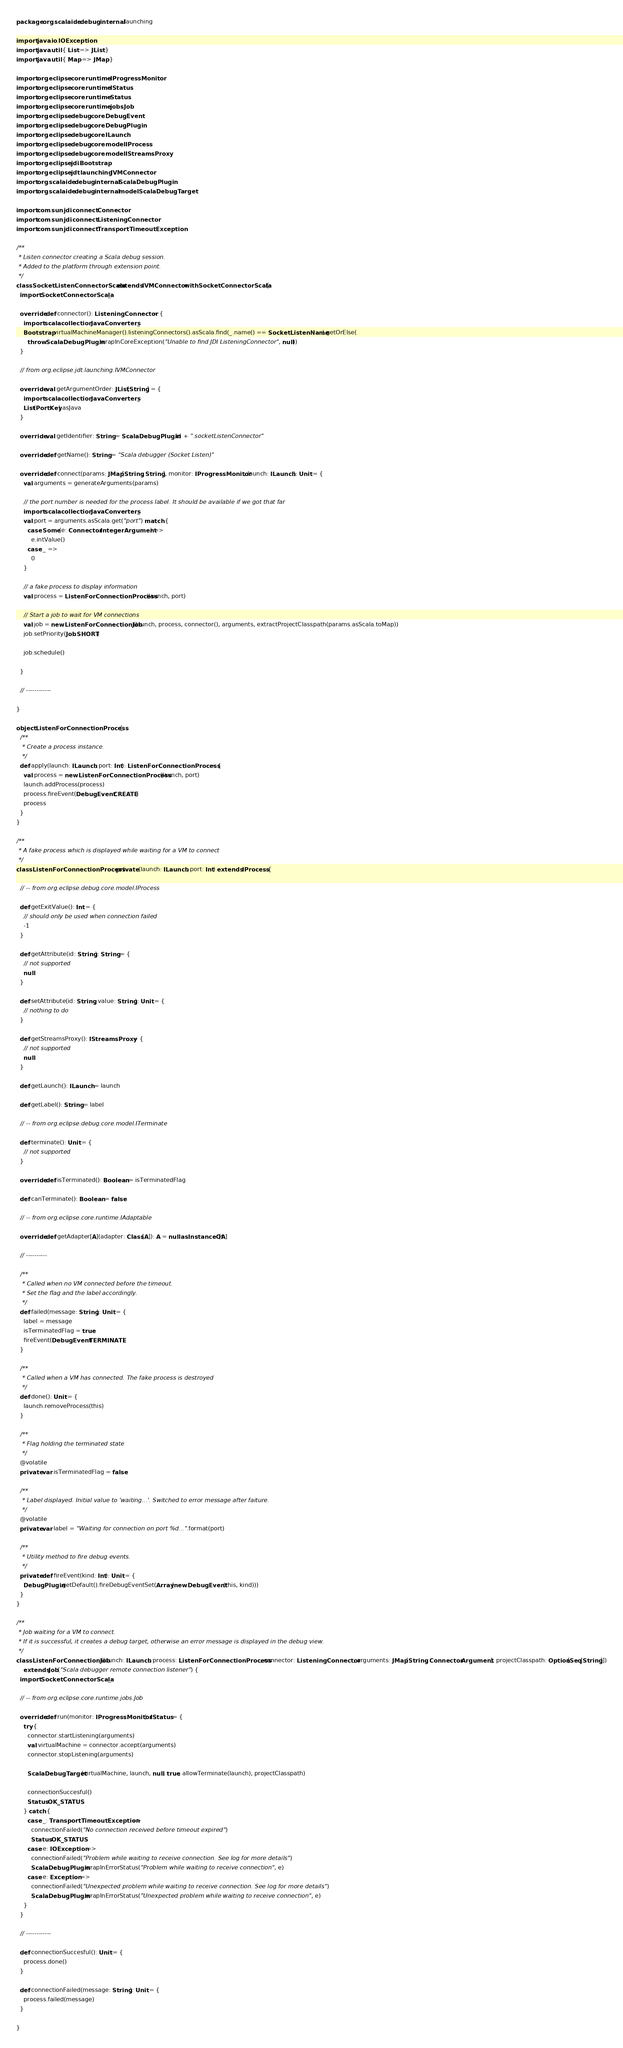<code> <loc_0><loc_0><loc_500><loc_500><_Scala_>package org.scalaide.debug.internal.launching

import java.io.IOException
import java.util.{ List => JList }
import java.util.{ Map => JMap }

import org.eclipse.core.runtime.IProgressMonitor
import org.eclipse.core.runtime.IStatus
import org.eclipse.core.runtime.Status
import org.eclipse.core.runtime.jobs.Job
import org.eclipse.debug.core.DebugEvent
import org.eclipse.debug.core.DebugPlugin
import org.eclipse.debug.core.ILaunch
import org.eclipse.debug.core.model.IProcess
import org.eclipse.debug.core.model.IStreamsProxy
import org.eclipse.jdi.Bootstrap
import org.eclipse.jdt.launching.IVMConnector
import org.scalaide.debug.internal.ScalaDebugPlugin
import org.scalaide.debug.internal.model.ScalaDebugTarget

import com.sun.jdi.connect.Connector
import com.sun.jdi.connect.ListeningConnector
import com.sun.jdi.connect.TransportTimeoutException

/**
 * Listen connector creating a Scala debug session.
 * Added to the platform through extension point.
 */
class SocketListenConnectorScala extends IVMConnector with SocketConnectorScala {
  import SocketConnectorScala._

  override def connector(): ListeningConnector = {
    import scala.collection.JavaConverters._
    Bootstrap.virtualMachineManager().listeningConnectors().asScala.find(_.name() == SocketListenName).getOrElse(
      throw ScalaDebugPlugin.wrapInCoreException("Unable to find JDI ListeningConnector", null))
  }

  // from org.eclipse.jdt.launching.IVMConnector

  override val getArgumentOrder: JList[String] = {
    import scala.collection.JavaConverters._
    List(PortKey).asJava
  }

  override val getIdentifier: String = ScalaDebugPlugin.id + ".socketListenConnector"

  override def getName(): String = "Scala debugger (Socket Listen)"

  override def connect(params: JMap[String, String], monitor: IProgressMonitor, launch: ILaunch): Unit = {
    val arguments = generateArguments(params)

    // the port number is needed for the process label. It should be available if we got that far
    import scala.collection.JavaConverters._
    val port = arguments.asScala.get("port") match {
      case Some(e: Connector.IntegerArgument) =>
        e.intValue()
      case _ =>
        0
    }

    // a fake process to display information
    val process = ListenForConnectionProcess(launch, port)

    // Start a job to wait for VM connections
    val job = new ListenForConnectionJob(launch, process, connector(), arguments, extractProjectClasspath(params.asScala.toMap))
    job.setPriority(Job.SHORT)

    job.schedule()

  }

  // ------------

}

object ListenForConnectionProcess {
  /**
   * Create a process instance.
   */
  def apply(launch: ILaunch, port: Int): ListenForConnectionProcess = {
    val process = new ListenForConnectionProcess(launch, port)
    launch.addProcess(process)
    process.fireEvent(DebugEvent.CREATE)
    process
  }
}

/**
 * A fake process which is displayed while waiting for a VM to connect
 */
class ListenForConnectionProcess private (launch: ILaunch, port: Int) extends IProcess {

  // -- from org.eclipse.debug.core.model.IProcess

  def getExitValue(): Int = {
    // should only be used when connection failed
    -1
  }

  def getAttribute(id: String): String = {
    // not supported
    null
  }

  def setAttribute(id: String, value: String): Unit = {
    // nothing to do
  }

  def getStreamsProxy(): IStreamsProxy = {
    // not supported
    null
  }

  def getLaunch(): ILaunch = launch

  def getLabel(): String = label

  // -- from org.eclipse.debug.core.model.ITerminate

  def terminate(): Unit = {
    // not supported
  }

  override def isTerminated(): Boolean = isTerminatedFlag

  def canTerminate(): Boolean = false

  // -- from org.eclipse.core.runtime.IAdaptable

  override def getAdapter[A](adapter: Class[A]): A = null.asInstanceOf[A]

  // ----------

  /**
   * Called when no VM connected before the timeout.
   * Set the flag and the label accordingly.
   */
  def failed(message: String): Unit = {
    label = message
    isTerminatedFlag = true
    fireEvent(DebugEvent.TERMINATE)
  }

  /**
   * Called when a VM has connected. The fake process is destroyed
   */
  def done(): Unit = {
    launch.removeProcess(this)
  }

  /**
   * Flag holding the terminated state
   */
  @volatile
  private var isTerminatedFlag = false

  /**
   * Label displayed. Initial value to 'waiting...'. Switched to error message after faiture.
   */
  @volatile
  private var label = "Waiting for connection on port %d...".format(port)

  /**
   * Utility method to fire debug events.
   */
  private def fireEvent(kind: Int): Unit = {
    DebugPlugin.getDefault().fireDebugEventSet(Array(new DebugEvent(this, kind)))
  }
}

/**
 * Job waiting for a VM to connect.
 * If it is successful, it creates a debug target, otherwise an error message is displayed in the debug view.
 */
class ListenForConnectionJob(launch: ILaunch, process: ListenForConnectionProcess, connector: ListeningConnector, arguments: JMap[String, Connector.Argument], projectClasspath: Option[Seq[String]])
    extends Job("Scala debugger remote connection listener") {
  import SocketConnectorScala._

  // -- from org.eclipse.core.runtime.jobs.Job

  override def run(monitor: IProgressMonitor): IStatus = {
    try {
      connector.startListening(arguments)
      val virtualMachine = connector.accept(arguments)
      connector.stopListening(arguments)

      ScalaDebugTarget(virtualMachine, launch, null, true, allowTerminate(launch), projectClasspath)

      connectionSuccesful()
      Status.OK_STATUS
    } catch {
      case _: TransportTimeoutException =>
        connectionFailed("No connection received before timeout expired")
        Status.OK_STATUS
      case e: IOException =>
        connectionFailed("Problem while waiting to receive connection. See log for more details")
        ScalaDebugPlugin.wrapInErrorStatus("Problem while waiting to receive connection", e)
      case e: Exception =>
        connectionFailed("Unexpected problem while waiting to receive connection. See log for more details")
        ScalaDebugPlugin.wrapInErrorStatus("Unexpected problem while waiting to receive connection", e)
    }
  }

  // ------------

  def connectionSuccesful(): Unit = {
    process.done()
  }

  def connectionFailed(message: String): Unit = {
    process.failed(message)
  }

}
</code> 